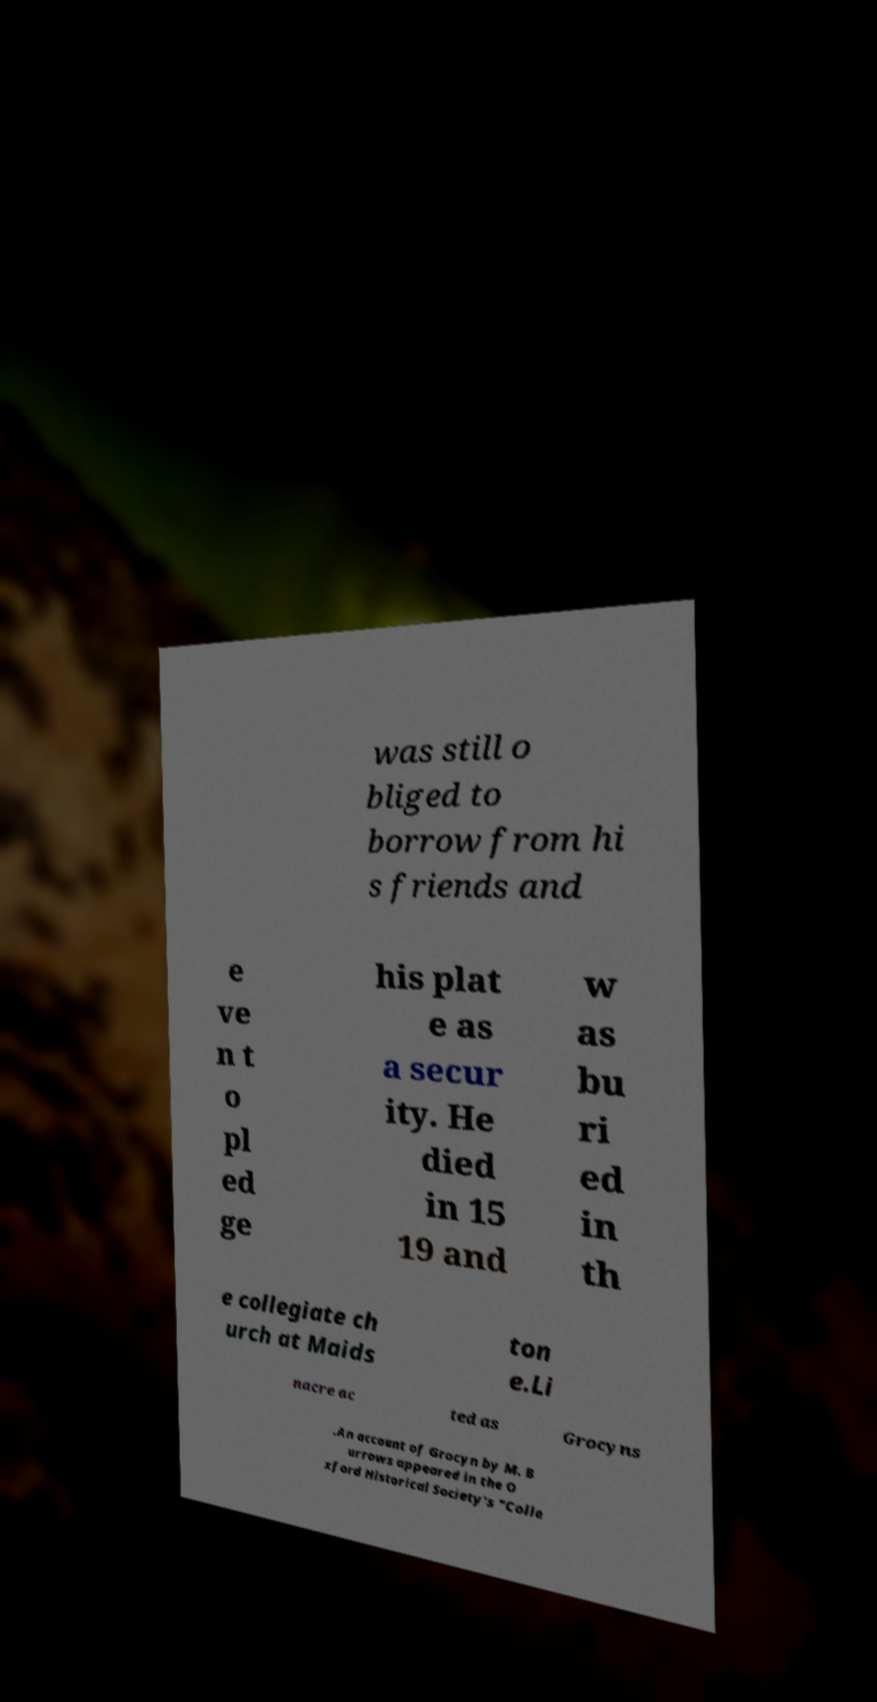Could you extract and type out the text from this image? was still o bliged to borrow from hi s friends and e ve n t o pl ed ge his plat e as a secur ity. He died in 15 19 and w as bu ri ed in th e collegiate ch urch at Maids ton e.Li nacre ac ted as Grocyns .An account of Grocyn by M. B urrows appeared in the O xford Historical Society's "Colle 